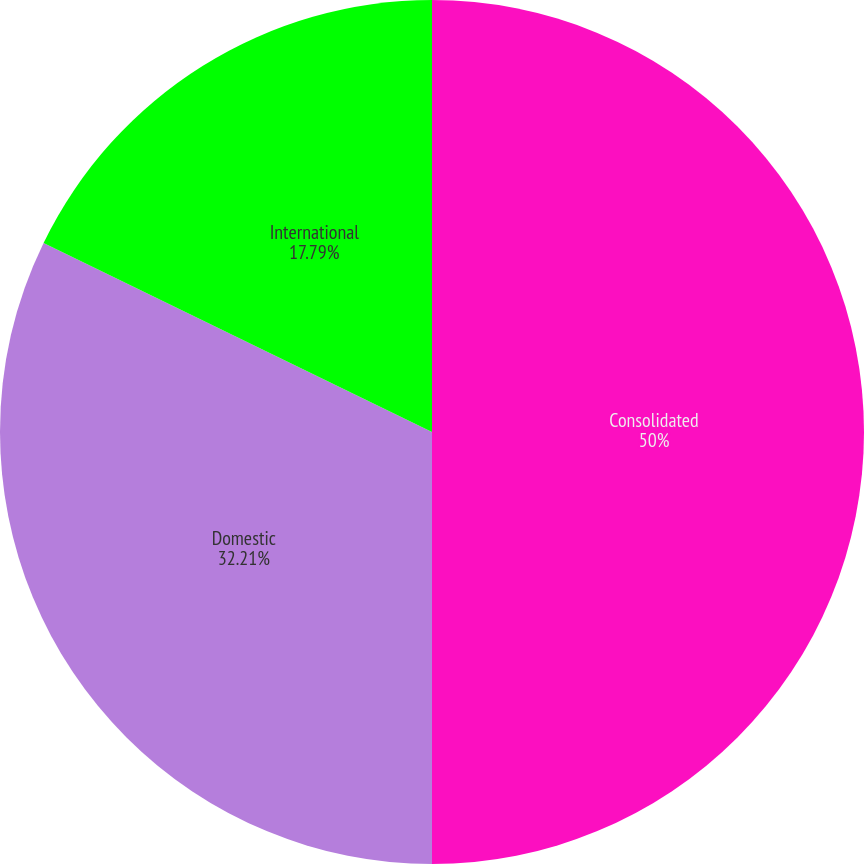<chart> <loc_0><loc_0><loc_500><loc_500><pie_chart><fcel>Consolidated<fcel>Domestic<fcel>International<nl><fcel>50.0%<fcel>32.21%<fcel>17.79%<nl></chart> 